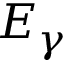Convert formula to latex. <formula><loc_0><loc_0><loc_500><loc_500>E _ { \gamma }</formula> 